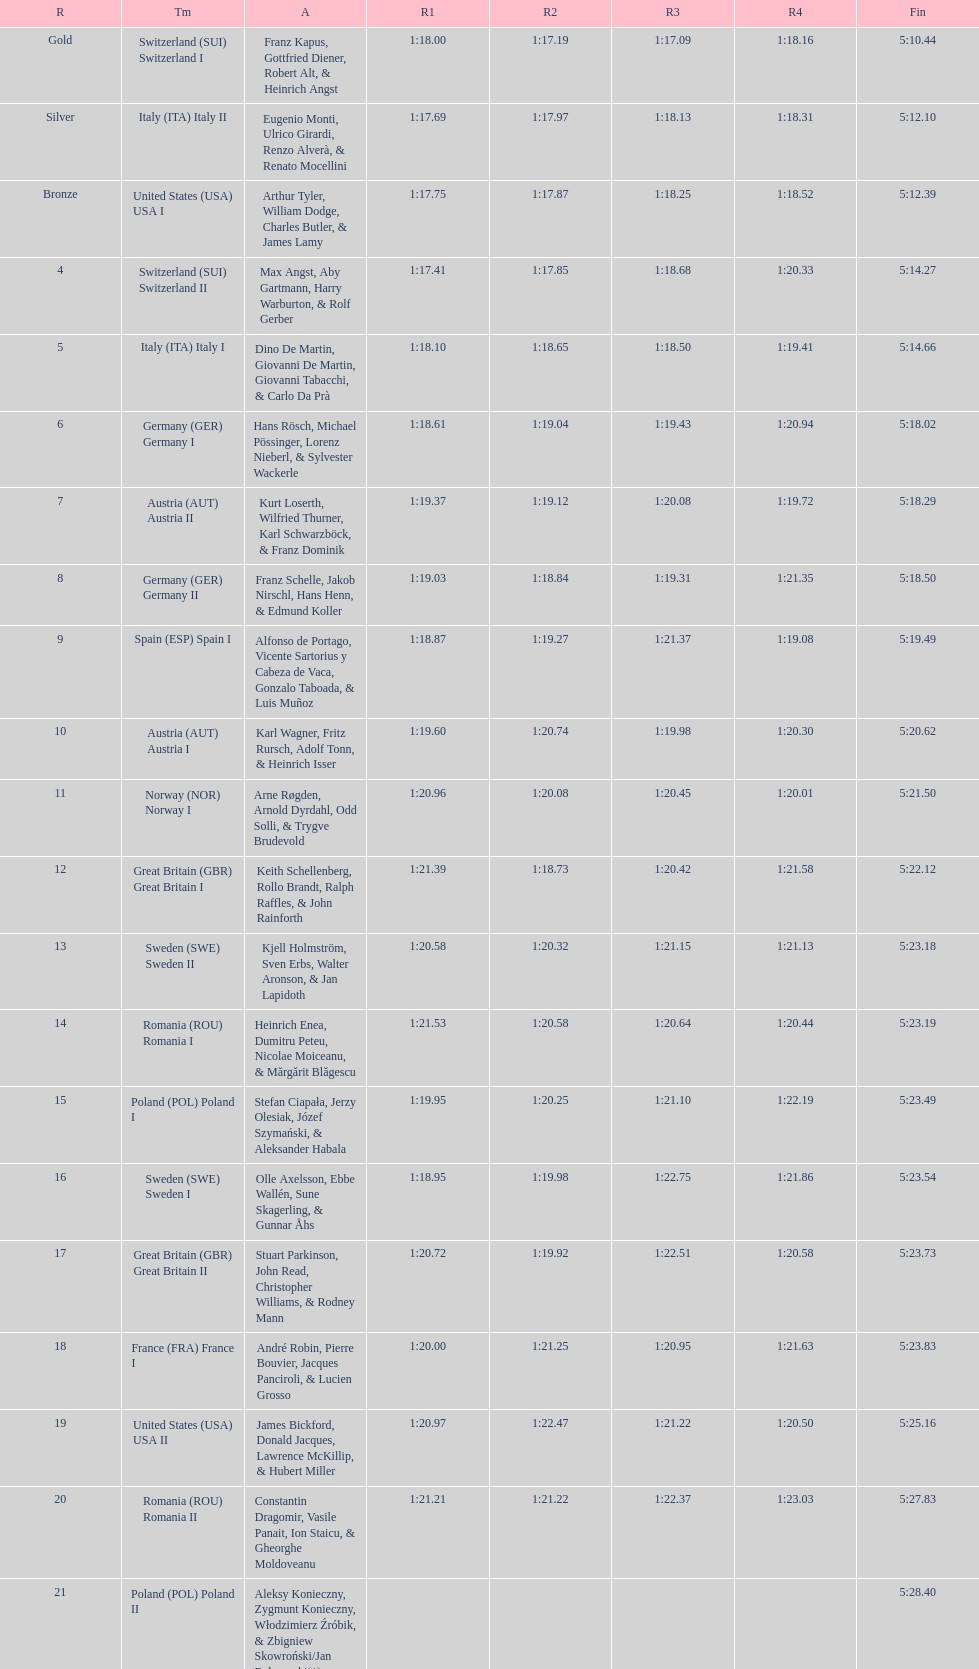What team came out on top? Switzerland. 